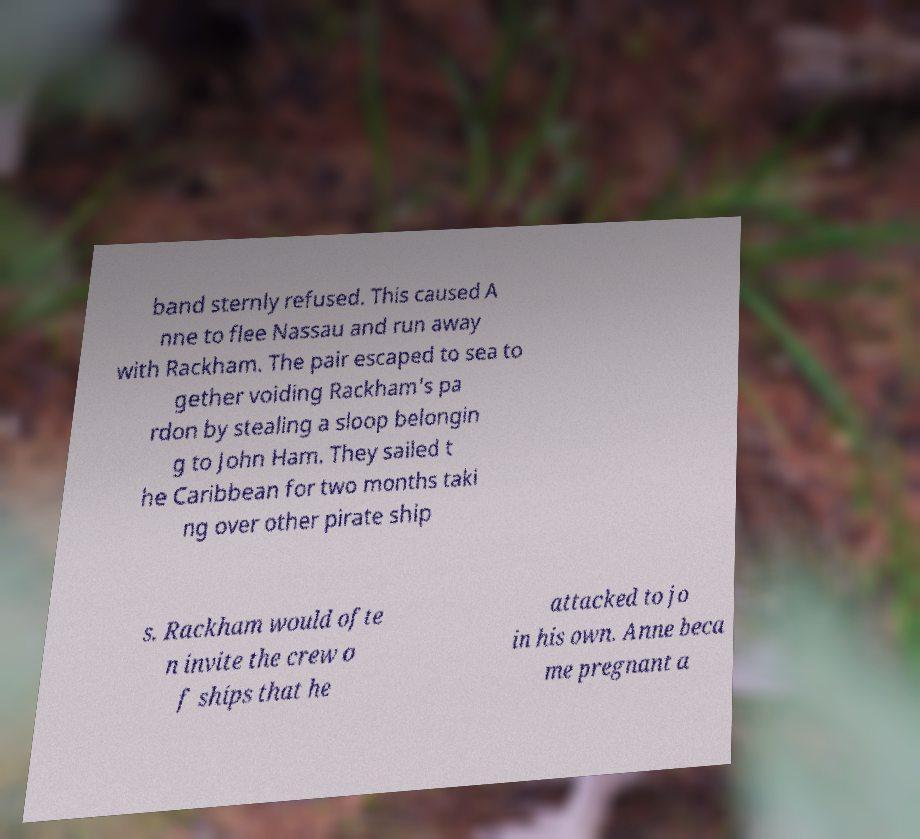Could you extract and type out the text from this image? band sternly refused. This caused A nne to flee Nassau and run away with Rackham. The pair escaped to sea to gether voiding Rackham's pa rdon by stealing a sloop belongin g to John Ham. They sailed t he Caribbean for two months taki ng over other pirate ship s. Rackham would ofte n invite the crew o f ships that he attacked to jo in his own. Anne beca me pregnant a 